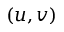Convert formula to latex. <formula><loc_0><loc_0><loc_500><loc_500>( u , v )</formula> 